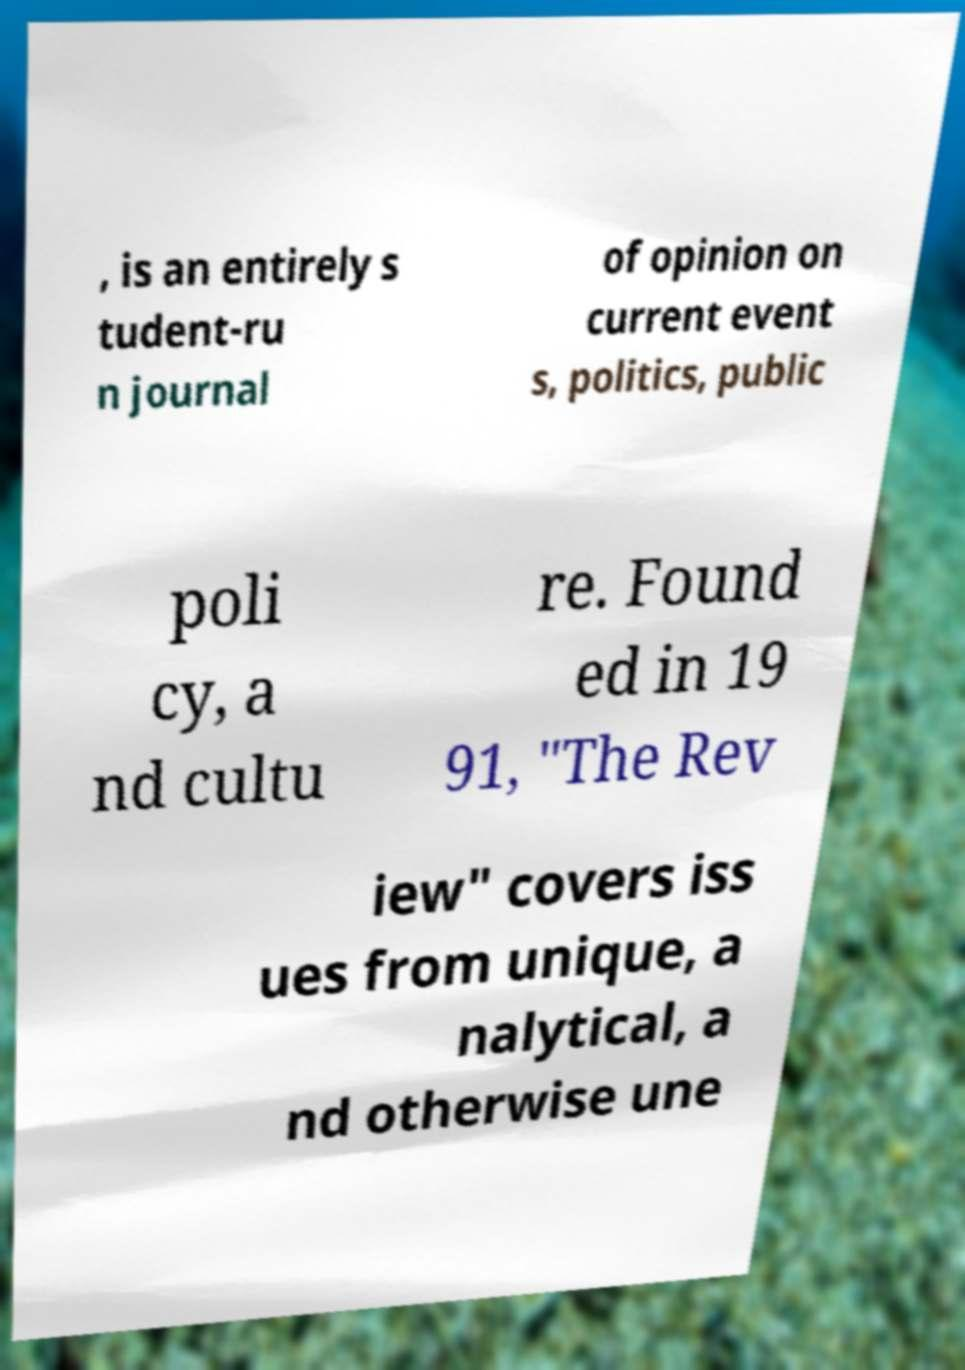Can you read and provide the text displayed in the image?This photo seems to have some interesting text. Can you extract and type it out for me? , is an entirely s tudent-ru n journal of opinion on current event s, politics, public poli cy, a nd cultu re. Found ed in 19 91, "The Rev iew" covers iss ues from unique, a nalytical, a nd otherwise une 